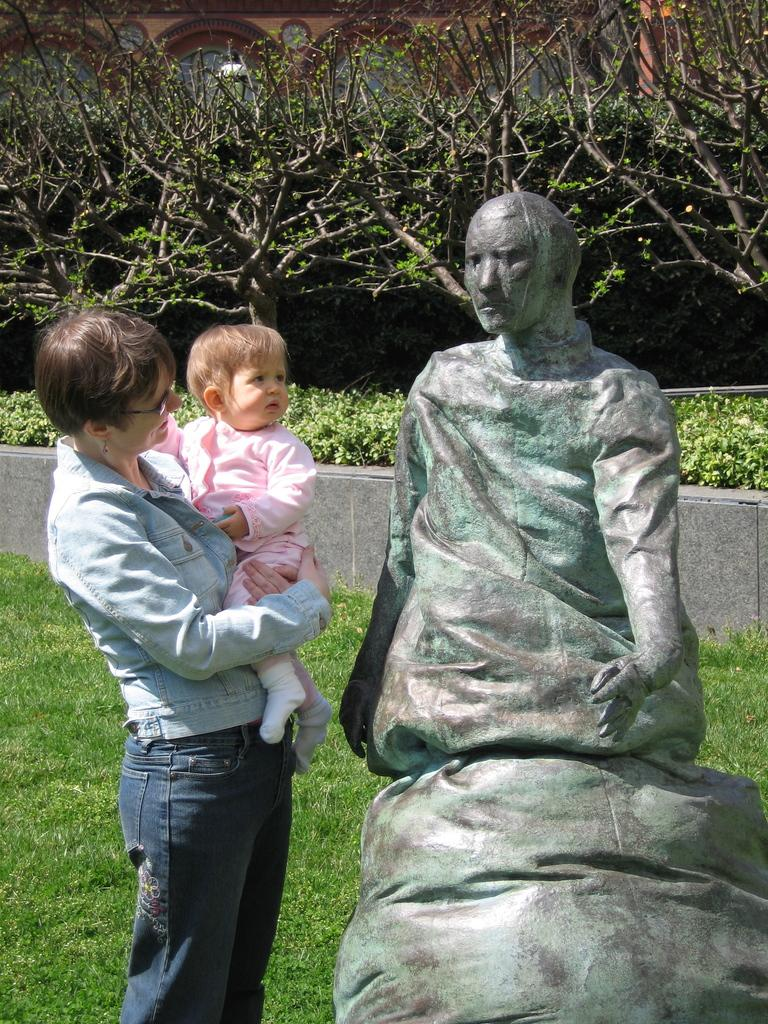Who is present on the left side of the image? There is a woman and a baby on the left side of the image. What can be seen on the right side of the image? There is a statue on the right side of the image. What type of vegetation is present in the image? There is grass on the ground in the image. What is visible in the background of the image? There are trees in the background of the image. What type of wool is being spun by the daughter in the image? There is no daughter or wool spinning activity present in the image. 